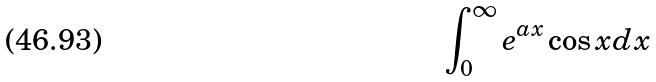<formula> <loc_0><loc_0><loc_500><loc_500>\int _ { 0 } ^ { \infty } e ^ { a x } \cos x d x</formula> 